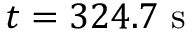<formula> <loc_0><loc_0><loc_500><loc_500>t = 3 2 4 . 7 s</formula> 